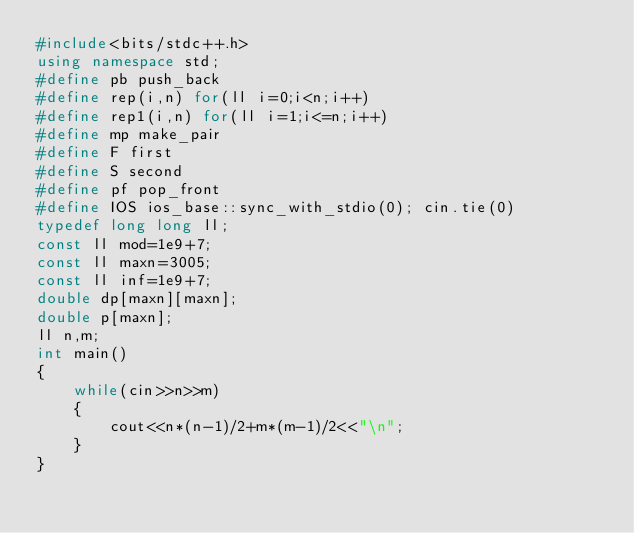Convert code to text. <code><loc_0><loc_0><loc_500><loc_500><_C++_>#include<bits/stdc++.h>
using namespace std;
#define pb push_back
#define rep(i,n) for(ll i=0;i<n;i++)
#define rep1(i,n) for(ll i=1;i<=n;i++)
#define mp make_pair
#define F first
#define S second
#define pf pop_front
#define IOS ios_base::sync_with_stdio(0); cin.tie(0)
typedef long long ll;
const ll mod=1e9+7;
const ll maxn=3005;
const ll inf=1e9+7;
double dp[maxn][maxn];
double p[maxn];
ll n,m;
int main()
{
    while(cin>>n>>m)
    {
        cout<<n*(n-1)/2+m*(m-1)/2<<"\n";
    }
}
</code> 